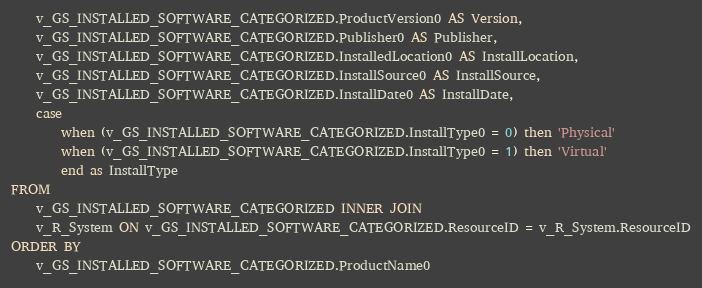Convert code to text. <code><loc_0><loc_0><loc_500><loc_500><_SQL_>	v_GS_INSTALLED_SOFTWARE_CATEGORIZED.ProductVersion0 AS Version, 
	v_GS_INSTALLED_SOFTWARE_CATEGORIZED.Publisher0 AS Publisher, 
	v_GS_INSTALLED_SOFTWARE_CATEGORIZED.InstalledLocation0 AS InstallLocation, 
	v_GS_INSTALLED_SOFTWARE_CATEGORIZED.InstallSource0 AS InstallSource, 
	v_GS_INSTALLED_SOFTWARE_CATEGORIZED.InstallDate0 AS InstallDate, 
	case 
		when (v_GS_INSTALLED_SOFTWARE_CATEGORIZED.InstallType0 = 0) then 'Physical'
		when (v_GS_INSTALLED_SOFTWARE_CATEGORIZED.InstallType0 = 1) then 'Virtual' 
		end as InstallType
FROM 
	v_GS_INSTALLED_SOFTWARE_CATEGORIZED INNER JOIN
	v_R_System ON v_GS_INSTALLED_SOFTWARE_CATEGORIZED.ResourceID = v_R_System.ResourceID
ORDER BY 
	v_GS_INSTALLED_SOFTWARE_CATEGORIZED.ProductName0</code> 